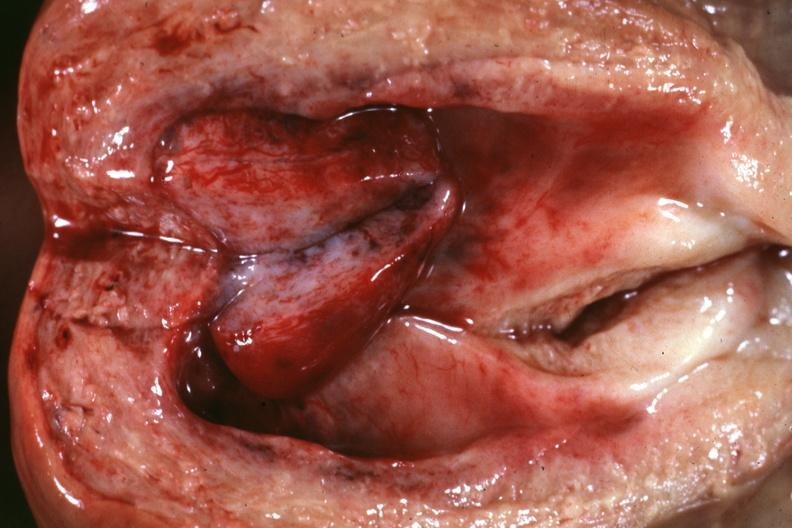s granulomata slide present?
Answer the question using a single word or phrase. No 